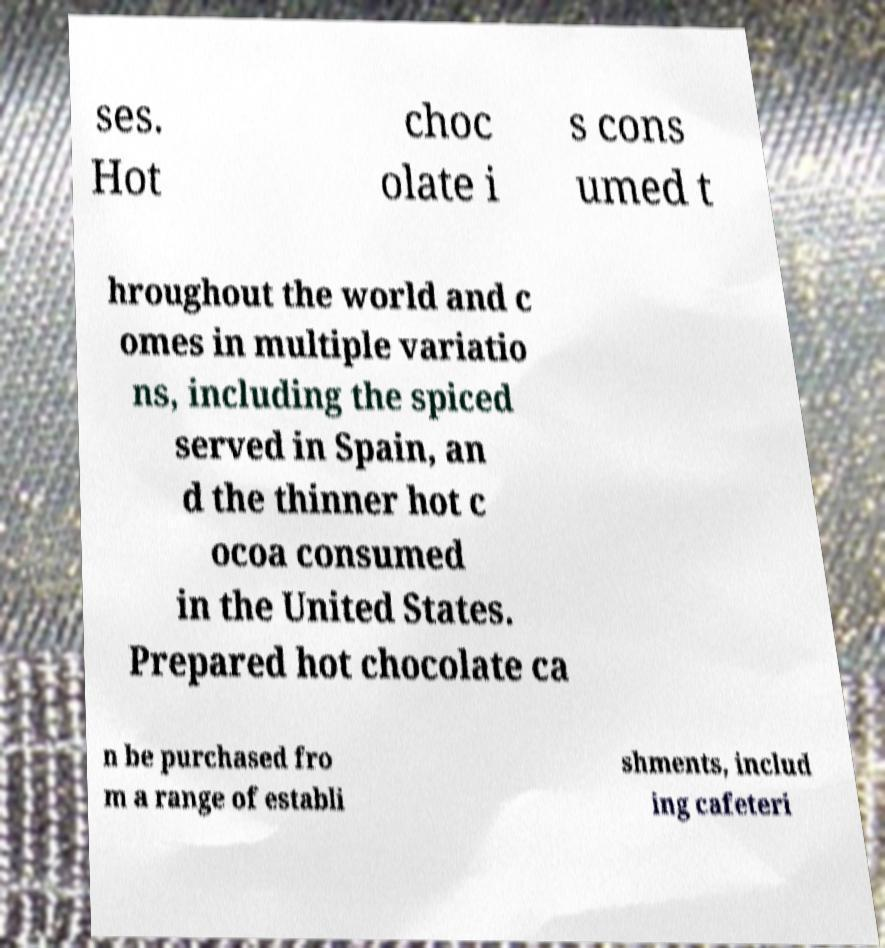Please identify and transcribe the text found in this image. ses. Hot choc olate i s cons umed t hroughout the world and c omes in multiple variatio ns, including the spiced served in Spain, an d the thinner hot c ocoa consumed in the United States. Prepared hot chocolate ca n be purchased fro m a range of establi shments, includ ing cafeteri 